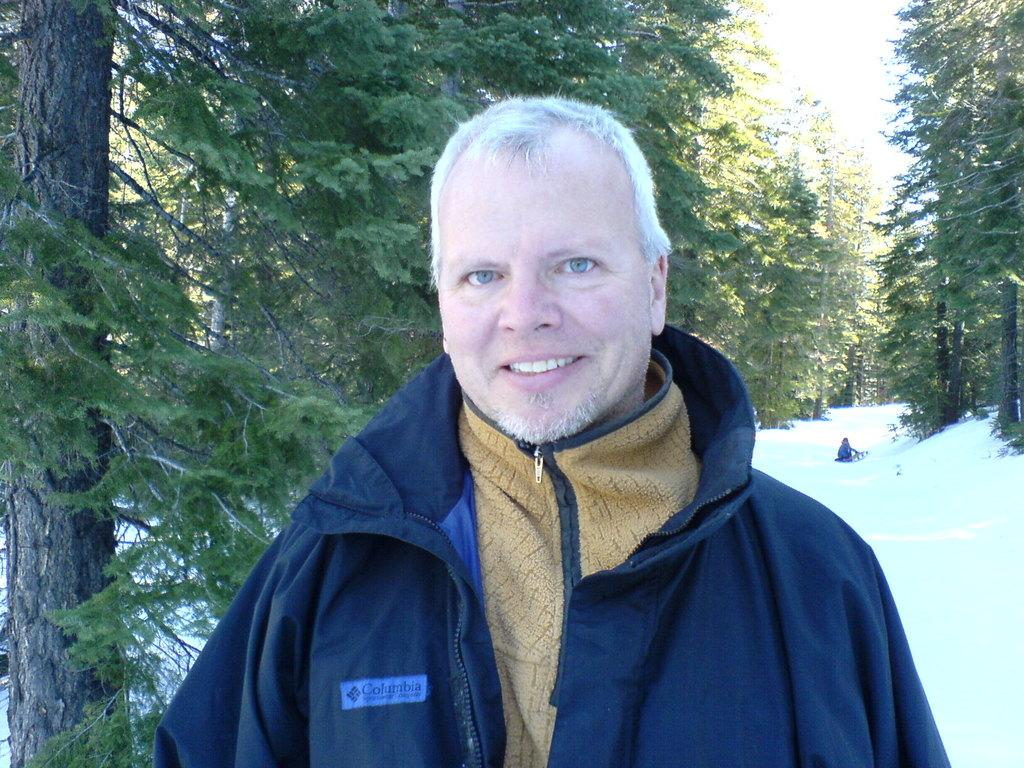What is the main subject of the image? There is a person in the image. What is the person wearing? The person is wearing a blue jacket. What can be seen in the background of the image? There are many trees in the background of the image. What is visible at the top of the image? The sky is visible at the top of the image. What is the ground covered with at the bottom of the image? There is snow at the bottom of the image. Can you hear the person laughing in the image? There is no sound in the image, so it is not possible to hear the person laughing. What type of wheel is visible in the image? There is no wheel present in the image. 